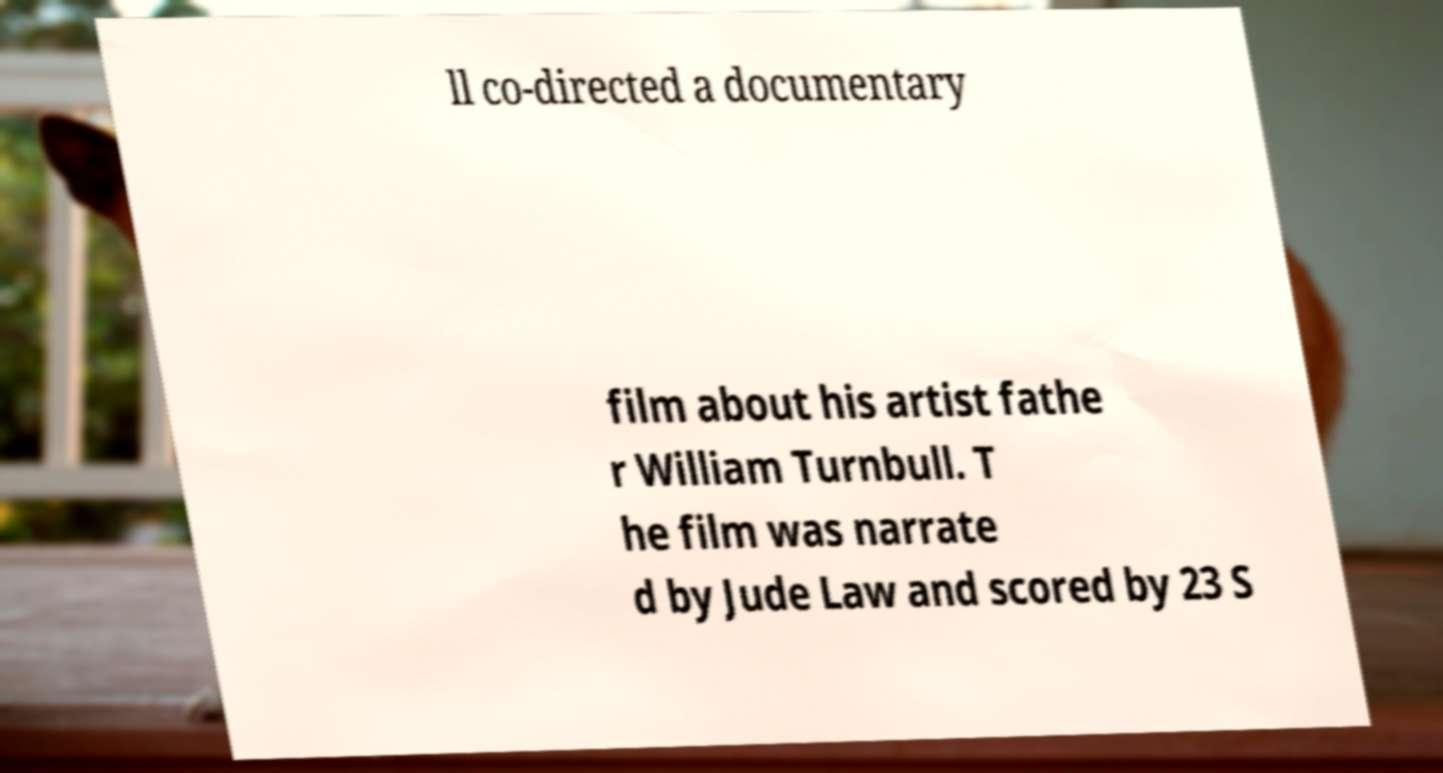What messages or text are displayed in this image? I need them in a readable, typed format. ll co-directed a documentary film about his artist fathe r William Turnbull. T he film was narrate d by Jude Law and scored by 23 S 